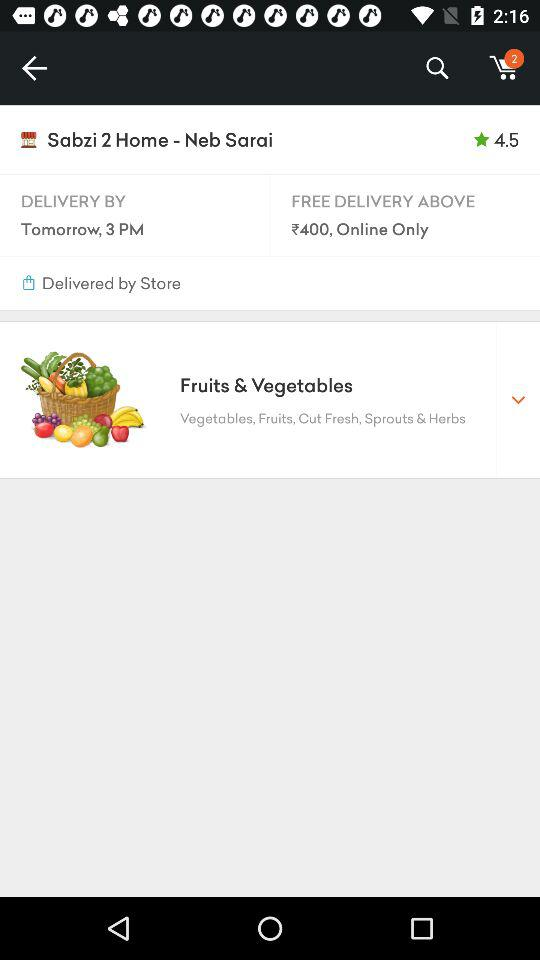Above what amount will the delivery be free? The delivery will be free above ₹400. 